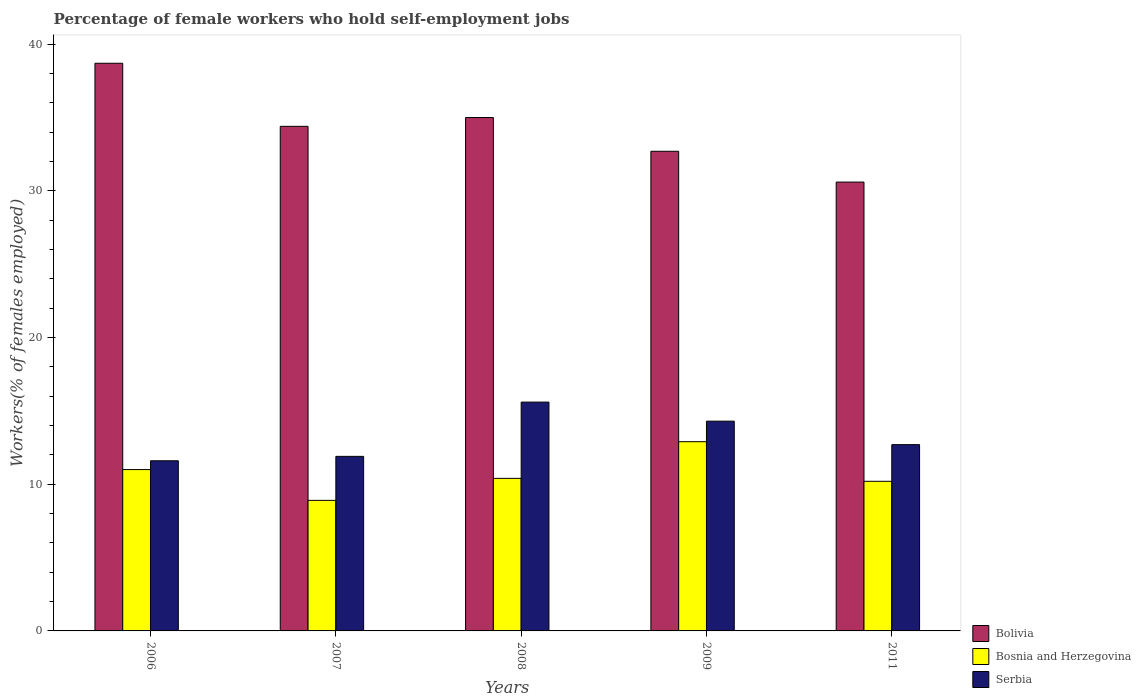How many bars are there on the 3rd tick from the left?
Provide a succinct answer. 3. What is the label of the 3rd group of bars from the left?
Offer a terse response. 2008. What is the percentage of self-employed female workers in Bosnia and Herzegovina in 2007?
Offer a very short reply. 8.9. Across all years, what is the maximum percentage of self-employed female workers in Bolivia?
Provide a succinct answer. 38.7. Across all years, what is the minimum percentage of self-employed female workers in Bolivia?
Offer a terse response. 30.6. In which year was the percentage of self-employed female workers in Serbia minimum?
Your answer should be compact. 2006. What is the total percentage of self-employed female workers in Serbia in the graph?
Ensure brevity in your answer.  66.1. What is the difference between the percentage of self-employed female workers in Bolivia in 2009 and that in 2011?
Your answer should be very brief. 2.1. What is the difference between the percentage of self-employed female workers in Bolivia in 2011 and the percentage of self-employed female workers in Bosnia and Herzegovina in 2009?
Your answer should be very brief. 17.7. What is the average percentage of self-employed female workers in Bosnia and Herzegovina per year?
Your response must be concise. 10.68. What is the ratio of the percentage of self-employed female workers in Serbia in 2007 to that in 2008?
Offer a terse response. 0.76. What is the difference between the highest and the second highest percentage of self-employed female workers in Bosnia and Herzegovina?
Provide a succinct answer. 1.9. In how many years, is the percentage of self-employed female workers in Bolivia greater than the average percentage of self-employed female workers in Bolivia taken over all years?
Your answer should be compact. 3. Is the sum of the percentage of self-employed female workers in Serbia in 2009 and 2011 greater than the maximum percentage of self-employed female workers in Bolivia across all years?
Provide a succinct answer. No. What does the 2nd bar from the left in 2009 represents?
Your answer should be compact. Bosnia and Herzegovina. What does the 2nd bar from the right in 2006 represents?
Your answer should be compact. Bosnia and Herzegovina. How many bars are there?
Keep it short and to the point. 15. Are all the bars in the graph horizontal?
Your response must be concise. No. What is the difference between two consecutive major ticks on the Y-axis?
Offer a terse response. 10. Are the values on the major ticks of Y-axis written in scientific E-notation?
Provide a succinct answer. No. Where does the legend appear in the graph?
Ensure brevity in your answer.  Bottom right. How many legend labels are there?
Your answer should be very brief. 3. How are the legend labels stacked?
Ensure brevity in your answer.  Vertical. What is the title of the graph?
Your response must be concise. Percentage of female workers who hold self-employment jobs. Does "Arab World" appear as one of the legend labels in the graph?
Provide a succinct answer. No. What is the label or title of the Y-axis?
Keep it short and to the point. Workers(% of females employed). What is the Workers(% of females employed) in Bolivia in 2006?
Provide a short and direct response. 38.7. What is the Workers(% of females employed) of Bosnia and Herzegovina in 2006?
Provide a succinct answer. 11. What is the Workers(% of females employed) in Serbia in 2006?
Give a very brief answer. 11.6. What is the Workers(% of females employed) of Bolivia in 2007?
Provide a succinct answer. 34.4. What is the Workers(% of females employed) of Bosnia and Herzegovina in 2007?
Provide a short and direct response. 8.9. What is the Workers(% of females employed) of Serbia in 2007?
Give a very brief answer. 11.9. What is the Workers(% of females employed) in Bosnia and Herzegovina in 2008?
Your response must be concise. 10.4. What is the Workers(% of females employed) of Serbia in 2008?
Provide a short and direct response. 15.6. What is the Workers(% of females employed) of Bolivia in 2009?
Make the answer very short. 32.7. What is the Workers(% of females employed) of Bosnia and Herzegovina in 2009?
Provide a succinct answer. 12.9. What is the Workers(% of females employed) in Serbia in 2009?
Provide a succinct answer. 14.3. What is the Workers(% of females employed) in Bolivia in 2011?
Make the answer very short. 30.6. What is the Workers(% of females employed) in Bosnia and Herzegovina in 2011?
Keep it short and to the point. 10.2. What is the Workers(% of females employed) of Serbia in 2011?
Offer a terse response. 12.7. Across all years, what is the maximum Workers(% of females employed) of Bolivia?
Your response must be concise. 38.7. Across all years, what is the maximum Workers(% of females employed) in Bosnia and Herzegovina?
Provide a succinct answer. 12.9. Across all years, what is the maximum Workers(% of females employed) of Serbia?
Provide a succinct answer. 15.6. Across all years, what is the minimum Workers(% of females employed) of Bolivia?
Keep it short and to the point. 30.6. Across all years, what is the minimum Workers(% of females employed) in Bosnia and Herzegovina?
Give a very brief answer. 8.9. Across all years, what is the minimum Workers(% of females employed) of Serbia?
Offer a very short reply. 11.6. What is the total Workers(% of females employed) in Bolivia in the graph?
Your answer should be very brief. 171.4. What is the total Workers(% of females employed) of Bosnia and Herzegovina in the graph?
Make the answer very short. 53.4. What is the total Workers(% of females employed) in Serbia in the graph?
Ensure brevity in your answer.  66.1. What is the difference between the Workers(% of females employed) in Bolivia in 2006 and that in 2007?
Your answer should be compact. 4.3. What is the difference between the Workers(% of females employed) of Bosnia and Herzegovina in 2006 and that in 2007?
Provide a succinct answer. 2.1. What is the difference between the Workers(% of females employed) of Serbia in 2006 and that in 2007?
Your answer should be compact. -0.3. What is the difference between the Workers(% of females employed) in Bolivia in 2006 and that in 2008?
Offer a terse response. 3.7. What is the difference between the Workers(% of females employed) in Bosnia and Herzegovina in 2006 and that in 2008?
Your answer should be very brief. 0.6. What is the difference between the Workers(% of females employed) of Bolivia in 2006 and that in 2011?
Give a very brief answer. 8.1. What is the difference between the Workers(% of females employed) of Serbia in 2006 and that in 2011?
Offer a very short reply. -1.1. What is the difference between the Workers(% of females employed) in Bosnia and Herzegovina in 2007 and that in 2008?
Your response must be concise. -1.5. What is the difference between the Workers(% of females employed) of Serbia in 2007 and that in 2008?
Keep it short and to the point. -3.7. What is the difference between the Workers(% of females employed) of Bolivia in 2007 and that in 2009?
Provide a succinct answer. 1.7. What is the difference between the Workers(% of females employed) of Bosnia and Herzegovina in 2007 and that in 2009?
Your answer should be very brief. -4. What is the difference between the Workers(% of females employed) of Serbia in 2007 and that in 2009?
Provide a succinct answer. -2.4. What is the difference between the Workers(% of females employed) in Bolivia in 2007 and that in 2011?
Offer a terse response. 3.8. What is the difference between the Workers(% of females employed) of Bosnia and Herzegovina in 2007 and that in 2011?
Provide a short and direct response. -1.3. What is the difference between the Workers(% of females employed) in Serbia in 2007 and that in 2011?
Your answer should be very brief. -0.8. What is the difference between the Workers(% of females employed) of Bolivia in 2008 and that in 2011?
Offer a very short reply. 4.4. What is the difference between the Workers(% of females employed) in Bosnia and Herzegovina in 2008 and that in 2011?
Your answer should be compact. 0.2. What is the difference between the Workers(% of females employed) in Bosnia and Herzegovina in 2009 and that in 2011?
Provide a short and direct response. 2.7. What is the difference between the Workers(% of females employed) in Serbia in 2009 and that in 2011?
Provide a succinct answer. 1.6. What is the difference between the Workers(% of females employed) in Bolivia in 2006 and the Workers(% of females employed) in Bosnia and Herzegovina in 2007?
Make the answer very short. 29.8. What is the difference between the Workers(% of females employed) in Bolivia in 2006 and the Workers(% of females employed) in Serbia in 2007?
Offer a terse response. 26.8. What is the difference between the Workers(% of females employed) in Bolivia in 2006 and the Workers(% of females employed) in Bosnia and Herzegovina in 2008?
Make the answer very short. 28.3. What is the difference between the Workers(% of females employed) of Bolivia in 2006 and the Workers(% of females employed) of Serbia in 2008?
Provide a succinct answer. 23.1. What is the difference between the Workers(% of females employed) of Bosnia and Herzegovina in 2006 and the Workers(% of females employed) of Serbia in 2008?
Offer a terse response. -4.6. What is the difference between the Workers(% of females employed) in Bolivia in 2006 and the Workers(% of females employed) in Bosnia and Herzegovina in 2009?
Offer a very short reply. 25.8. What is the difference between the Workers(% of females employed) of Bolivia in 2006 and the Workers(% of females employed) of Serbia in 2009?
Offer a very short reply. 24.4. What is the difference between the Workers(% of females employed) in Bolivia in 2006 and the Workers(% of females employed) in Bosnia and Herzegovina in 2011?
Your response must be concise. 28.5. What is the difference between the Workers(% of females employed) of Bolivia in 2006 and the Workers(% of females employed) of Serbia in 2011?
Give a very brief answer. 26. What is the difference between the Workers(% of females employed) of Bosnia and Herzegovina in 2006 and the Workers(% of females employed) of Serbia in 2011?
Your answer should be compact. -1.7. What is the difference between the Workers(% of females employed) in Bolivia in 2007 and the Workers(% of females employed) in Bosnia and Herzegovina in 2009?
Make the answer very short. 21.5. What is the difference between the Workers(% of females employed) in Bolivia in 2007 and the Workers(% of females employed) in Serbia in 2009?
Offer a very short reply. 20.1. What is the difference between the Workers(% of females employed) in Bosnia and Herzegovina in 2007 and the Workers(% of females employed) in Serbia in 2009?
Provide a short and direct response. -5.4. What is the difference between the Workers(% of females employed) in Bolivia in 2007 and the Workers(% of females employed) in Bosnia and Herzegovina in 2011?
Your answer should be compact. 24.2. What is the difference between the Workers(% of females employed) in Bolivia in 2007 and the Workers(% of females employed) in Serbia in 2011?
Your response must be concise. 21.7. What is the difference between the Workers(% of females employed) in Bolivia in 2008 and the Workers(% of females employed) in Bosnia and Herzegovina in 2009?
Offer a very short reply. 22.1. What is the difference between the Workers(% of females employed) of Bolivia in 2008 and the Workers(% of females employed) of Serbia in 2009?
Make the answer very short. 20.7. What is the difference between the Workers(% of females employed) of Bolivia in 2008 and the Workers(% of females employed) of Bosnia and Herzegovina in 2011?
Your answer should be very brief. 24.8. What is the difference between the Workers(% of females employed) of Bolivia in 2008 and the Workers(% of females employed) of Serbia in 2011?
Make the answer very short. 22.3. What is the difference between the Workers(% of females employed) in Bosnia and Herzegovina in 2008 and the Workers(% of females employed) in Serbia in 2011?
Your answer should be very brief. -2.3. What is the difference between the Workers(% of females employed) in Bolivia in 2009 and the Workers(% of females employed) in Bosnia and Herzegovina in 2011?
Ensure brevity in your answer.  22.5. What is the difference between the Workers(% of females employed) of Bolivia in 2009 and the Workers(% of females employed) of Serbia in 2011?
Provide a short and direct response. 20. What is the average Workers(% of females employed) of Bolivia per year?
Your answer should be compact. 34.28. What is the average Workers(% of females employed) in Bosnia and Herzegovina per year?
Ensure brevity in your answer.  10.68. What is the average Workers(% of females employed) of Serbia per year?
Keep it short and to the point. 13.22. In the year 2006, what is the difference between the Workers(% of females employed) in Bolivia and Workers(% of females employed) in Bosnia and Herzegovina?
Your answer should be very brief. 27.7. In the year 2006, what is the difference between the Workers(% of females employed) of Bolivia and Workers(% of females employed) of Serbia?
Offer a very short reply. 27.1. In the year 2007, what is the difference between the Workers(% of females employed) of Bolivia and Workers(% of females employed) of Bosnia and Herzegovina?
Provide a short and direct response. 25.5. In the year 2007, what is the difference between the Workers(% of females employed) of Bosnia and Herzegovina and Workers(% of females employed) of Serbia?
Provide a succinct answer. -3. In the year 2008, what is the difference between the Workers(% of females employed) of Bolivia and Workers(% of females employed) of Bosnia and Herzegovina?
Provide a succinct answer. 24.6. In the year 2008, what is the difference between the Workers(% of females employed) of Bolivia and Workers(% of females employed) of Serbia?
Your answer should be very brief. 19.4. In the year 2009, what is the difference between the Workers(% of females employed) in Bolivia and Workers(% of females employed) in Bosnia and Herzegovina?
Your response must be concise. 19.8. In the year 2011, what is the difference between the Workers(% of females employed) in Bolivia and Workers(% of females employed) in Bosnia and Herzegovina?
Your answer should be compact. 20.4. In the year 2011, what is the difference between the Workers(% of females employed) of Bosnia and Herzegovina and Workers(% of females employed) of Serbia?
Offer a very short reply. -2.5. What is the ratio of the Workers(% of females employed) in Bosnia and Herzegovina in 2006 to that in 2007?
Your answer should be very brief. 1.24. What is the ratio of the Workers(% of females employed) in Serbia in 2006 to that in 2007?
Keep it short and to the point. 0.97. What is the ratio of the Workers(% of females employed) of Bolivia in 2006 to that in 2008?
Offer a terse response. 1.11. What is the ratio of the Workers(% of females employed) of Bosnia and Herzegovina in 2006 to that in 2008?
Offer a terse response. 1.06. What is the ratio of the Workers(% of females employed) in Serbia in 2006 to that in 2008?
Give a very brief answer. 0.74. What is the ratio of the Workers(% of females employed) in Bolivia in 2006 to that in 2009?
Give a very brief answer. 1.18. What is the ratio of the Workers(% of females employed) in Bosnia and Herzegovina in 2006 to that in 2009?
Offer a very short reply. 0.85. What is the ratio of the Workers(% of females employed) in Serbia in 2006 to that in 2009?
Ensure brevity in your answer.  0.81. What is the ratio of the Workers(% of females employed) of Bolivia in 2006 to that in 2011?
Provide a short and direct response. 1.26. What is the ratio of the Workers(% of females employed) in Bosnia and Herzegovina in 2006 to that in 2011?
Make the answer very short. 1.08. What is the ratio of the Workers(% of females employed) of Serbia in 2006 to that in 2011?
Provide a succinct answer. 0.91. What is the ratio of the Workers(% of females employed) in Bolivia in 2007 to that in 2008?
Your answer should be compact. 0.98. What is the ratio of the Workers(% of females employed) in Bosnia and Herzegovina in 2007 to that in 2008?
Provide a short and direct response. 0.86. What is the ratio of the Workers(% of females employed) of Serbia in 2007 to that in 2008?
Keep it short and to the point. 0.76. What is the ratio of the Workers(% of females employed) of Bolivia in 2007 to that in 2009?
Offer a terse response. 1.05. What is the ratio of the Workers(% of females employed) in Bosnia and Herzegovina in 2007 to that in 2009?
Provide a short and direct response. 0.69. What is the ratio of the Workers(% of females employed) of Serbia in 2007 to that in 2009?
Provide a short and direct response. 0.83. What is the ratio of the Workers(% of females employed) in Bolivia in 2007 to that in 2011?
Your answer should be compact. 1.12. What is the ratio of the Workers(% of females employed) in Bosnia and Herzegovina in 2007 to that in 2011?
Give a very brief answer. 0.87. What is the ratio of the Workers(% of females employed) of Serbia in 2007 to that in 2011?
Provide a succinct answer. 0.94. What is the ratio of the Workers(% of females employed) in Bolivia in 2008 to that in 2009?
Make the answer very short. 1.07. What is the ratio of the Workers(% of females employed) in Bosnia and Herzegovina in 2008 to that in 2009?
Give a very brief answer. 0.81. What is the ratio of the Workers(% of females employed) of Bolivia in 2008 to that in 2011?
Make the answer very short. 1.14. What is the ratio of the Workers(% of females employed) in Bosnia and Herzegovina in 2008 to that in 2011?
Your answer should be compact. 1.02. What is the ratio of the Workers(% of females employed) of Serbia in 2008 to that in 2011?
Give a very brief answer. 1.23. What is the ratio of the Workers(% of females employed) in Bolivia in 2009 to that in 2011?
Offer a very short reply. 1.07. What is the ratio of the Workers(% of females employed) of Bosnia and Herzegovina in 2009 to that in 2011?
Offer a very short reply. 1.26. What is the ratio of the Workers(% of females employed) in Serbia in 2009 to that in 2011?
Offer a very short reply. 1.13. What is the difference between the highest and the second highest Workers(% of females employed) in Bosnia and Herzegovina?
Provide a short and direct response. 1.9. What is the difference between the highest and the second highest Workers(% of females employed) of Serbia?
Offer a very short reply. 1.3. What is the difference between the highest and the lowest Workers(% of females employed) of Bosnia and Herzegovina?
Your answer should be very brief. 4. What is the difference between the highest and the lowest Workers(% of females employed) of Serbia?
Your answer should be very brief. 4. 